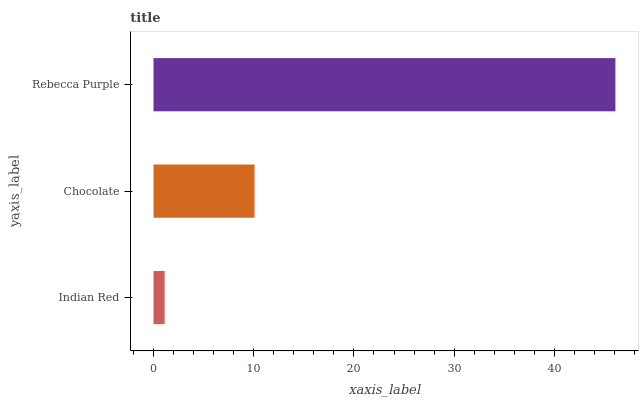Is Indian Red the minimum?
Answer yes or no. Yes. Is Rebecca Purple the maximum?
Answer yes or no. Yes. Is Chocolate the minimum?
Answer yes or no. No. Is Chocolate the maximum?
Answer yes or no. No. Is Chocolate greater than Indian Red?
Answer yes or no. Yes. Is Indian Red less than Chocolate?
Answer yes or no. Yes. Is Indian Red greater than Chocolate?
Answer yes or no. No. Is Chocolate less than Indian Red?
Answer yes or no. No. Is Chocolate the high median?
Answer yes or no. Yes. Is Chocolate the low median?
Answer yes or no. Yes. Is Indian Red the high median?
Answer yes or no. No. Is Indian Red the low median?
Answer yes or no. No. 